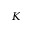<formula> <loc_0><loc_0><loc_500><loc_500>K</formula> 